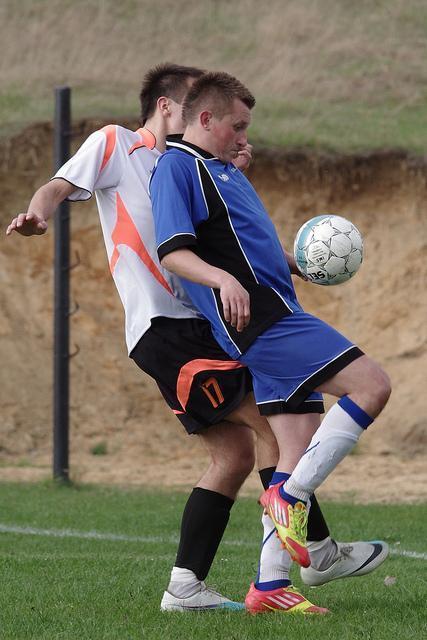How many people are in the photo?
Give a very brief answer. 2. 